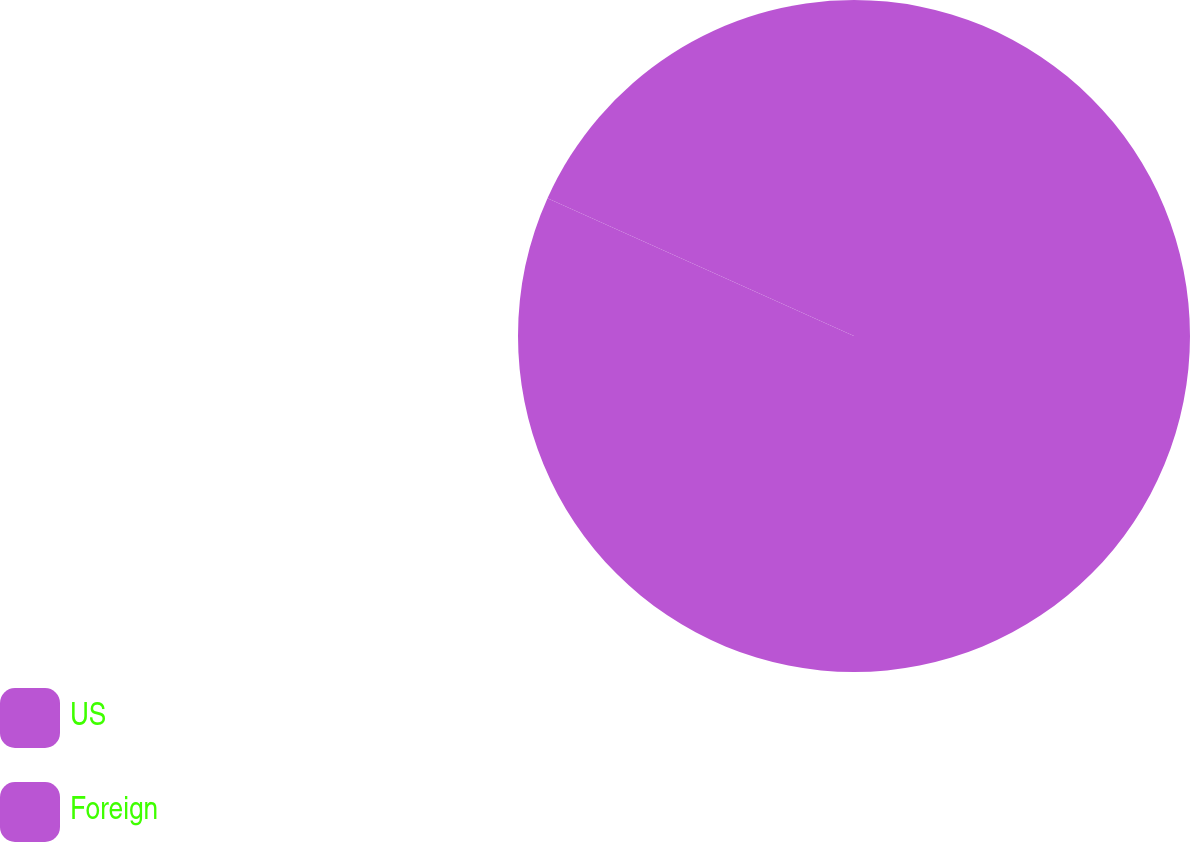<chart> <loc_0><loc_0><loc_500><loc_500><pie_chart><fcel>US<fcel>Foreign<nl><fcel>81.72%<fcel>18.28%<nl></chart> 